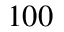Convert formula to latex. <formula><loc_0><loc_0><loc_500><loc_500>1 0 0</formula> 